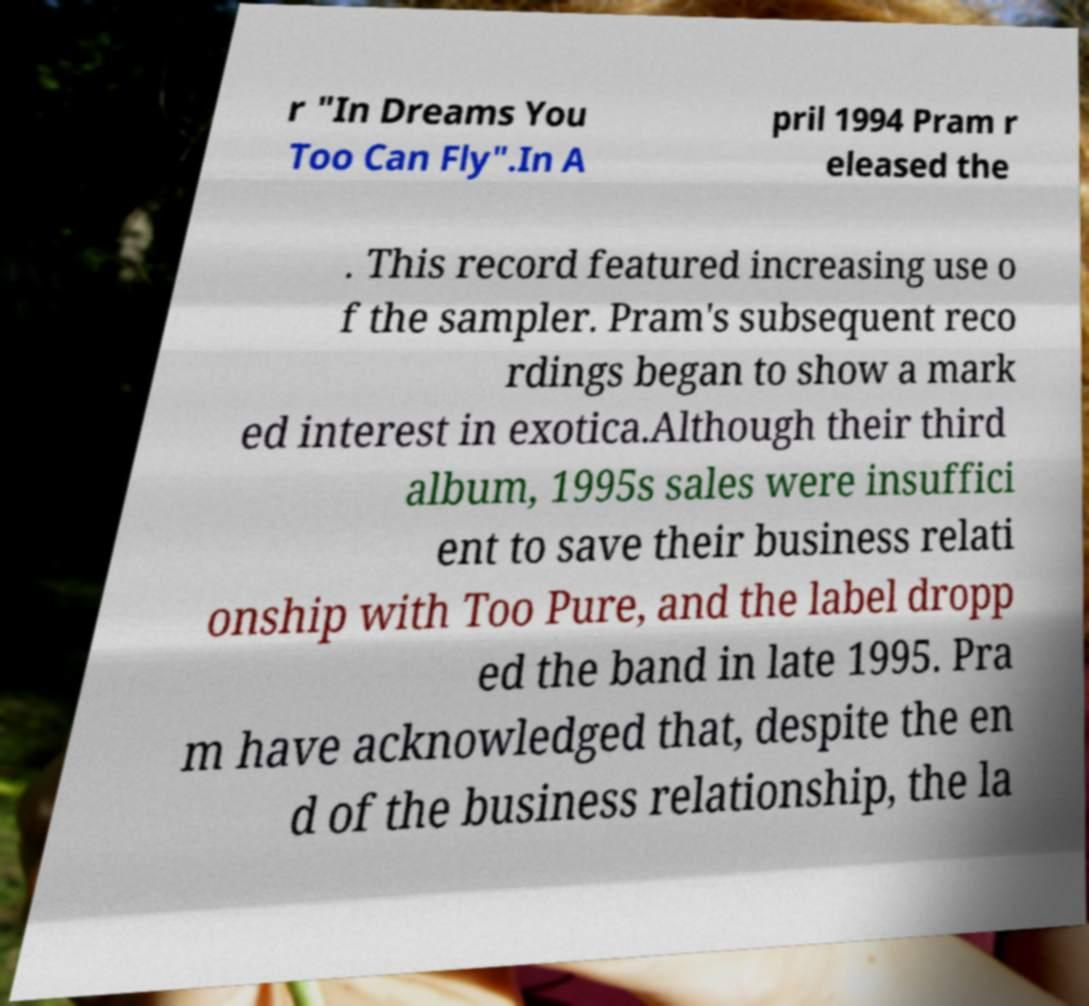What messages or text are displayed in this image? I need them in a readable, typed format. r "In Dreams You Too Can Fly".In A pril 1994 Pram r eleased the . This record featured increasing use o f the sampler. Pram's subsequent reco rdings began to show a mark ed interest in exotica.Although their third album, 1995s sales were insuffici ent to save their business relati onship with Too Pure, and the label dropp ed the band in late 1995. Pra m have acknowledged that, despite the en d of the business relationship, the la 